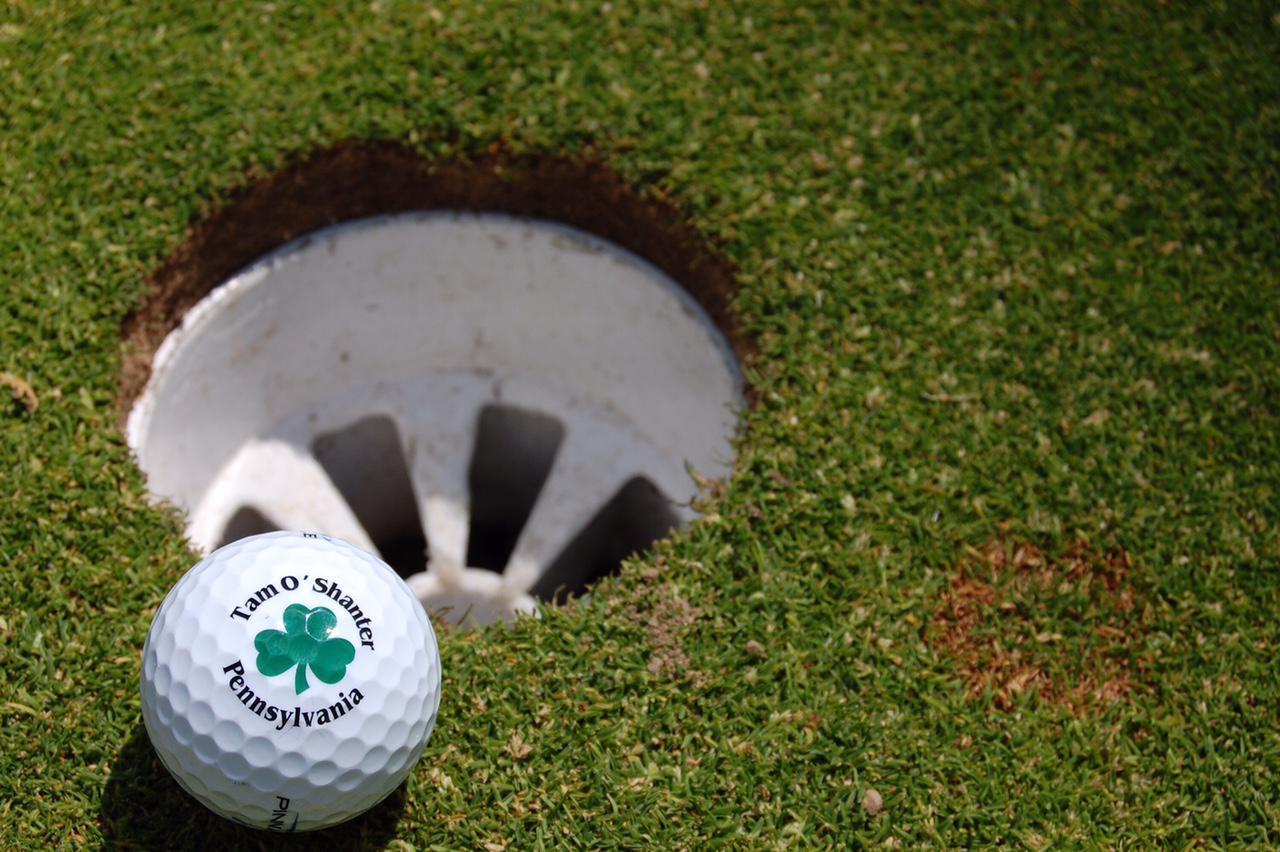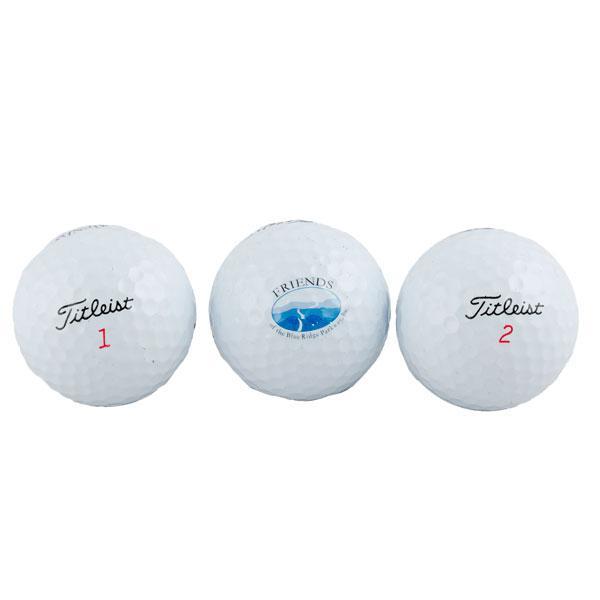The first image is the image on the left, the second image is the image on the right. For the images displayed, is the sentence "An image shows at least one golf ball on the green ground near a hole." factually correct? Answer yes or no. Yes. 